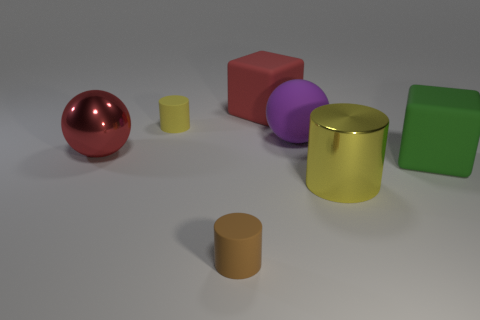Does the big red block have the same material as the red thing in front of the large purple rubber sphere?
Offer a terse response. No. Is the number of brown rubber things greater than the number of gray matte things?
Provide a short and direct response. Yes. What shape is the small object behind the large metallic object in front of the big thing that is on the left side of the tiny brown cylinder?
Your response must be concise. Cylinder. Are the thing in front of the big yellow cylinder and the small object behind the yellow shiny cylinder made of the same material?
Provide a short and direct response. Yes. What shape is the large purple object that is made of the same material as the red block?
Offer a terse response. Sphere. Are there any other things that are the same color as the metallic cylinder?
Your answer should be compact. Yes. What number of tiny green rubber balls are there?
Give a very brief answer. 0. What is the yellow cylinder in front of the red thing that is to the left of the tiny brown object made of?
Provide a succinct answer. Metal. There is a rubber cube in front of the small matte cylinder that is behind the rubber block in front of the large shiny sphere; what is its color?
Your answer should be compact. Green. How many green things have the same size as the brown cylinder?
Offer a very short reply. 0. 